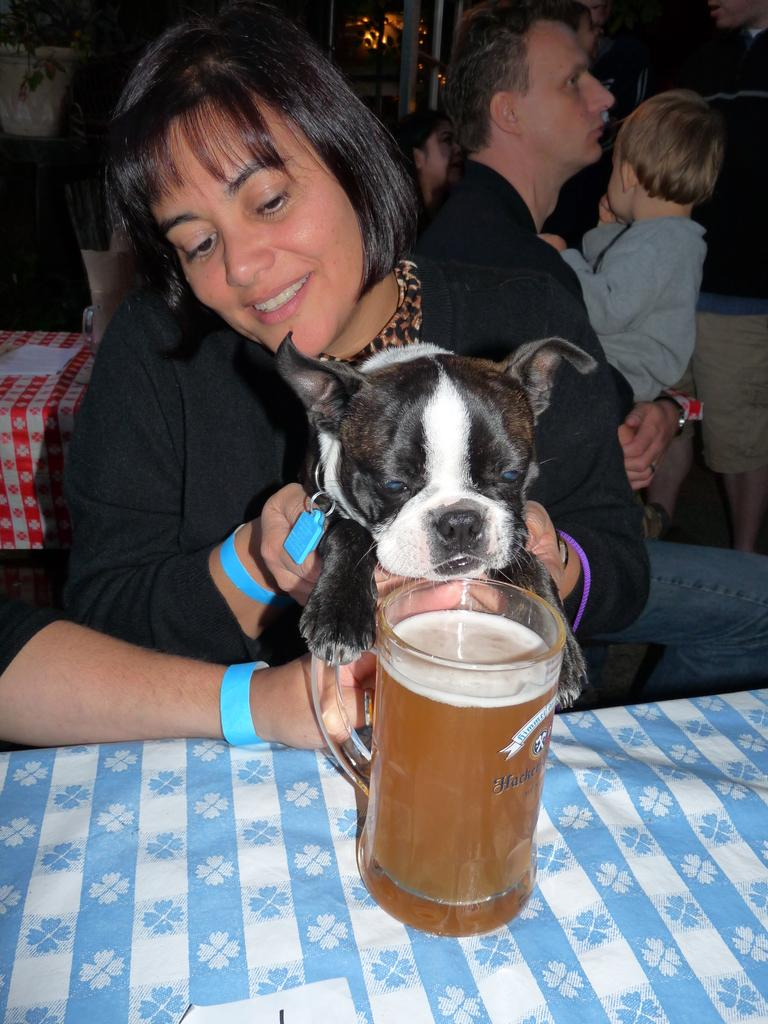Who is the main subject in the image? There is a woman in the image. What is the woman doing in the image? The woman is holding a dog. What is the dog's behavior in the image? The dog is looking at a drink. Can you describe the man in the background of the image? There is a man in the background of the image, and he is carrying a baby in his hands. What items are visible in the image related to cleaning or wiping? There is cloth and tissues visible in the image. What type of engine can be seen in the background of the image? There is no engine present in the image. What discovery was made by the woman in the image? There is no mention of a discovery in the image. 